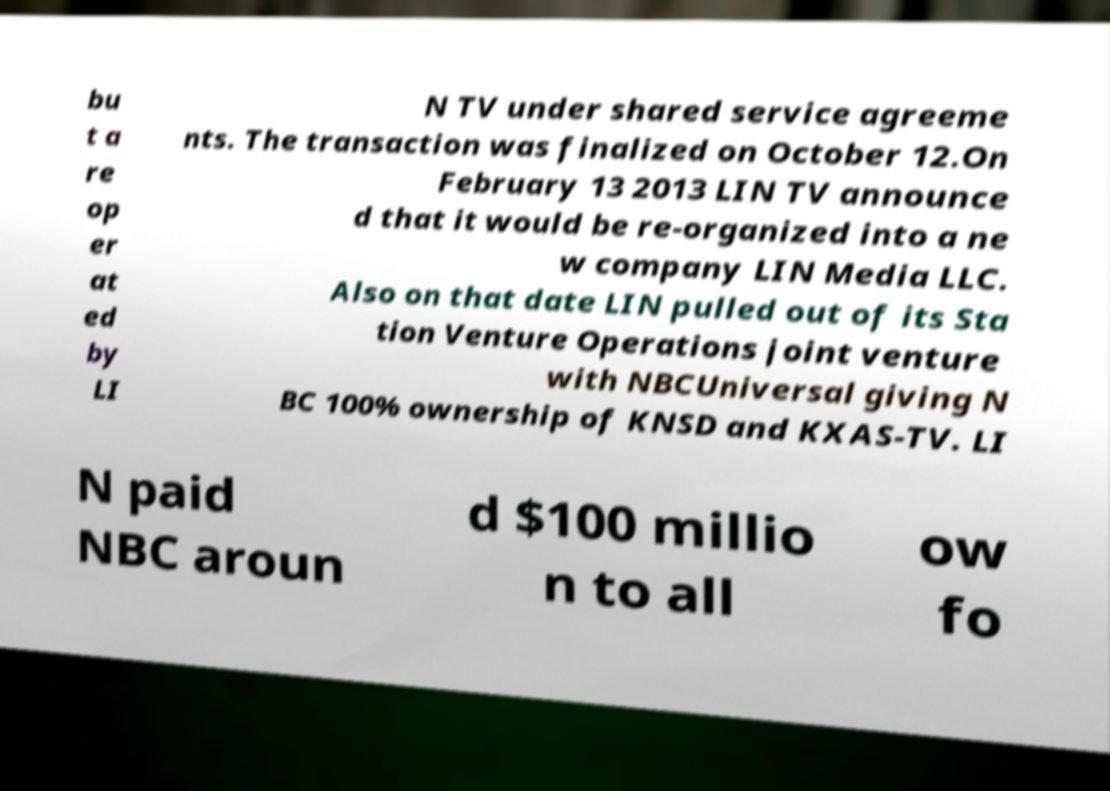Can you accurately transcribe the text from the provided image for me? bu t a re op er at ed by LI N TV under shared service agreeme nts. The transaction was finalized on October 12.On February 13 2013 LIN TV announce d that it would be re-organized into a ne w company LIN Media LLC. Also on that date LIN pulled out of its Sta tion Venture Operations joint venture with NBCUniversal giving N BC 100% ownership of KNSD and KXAS-TV. LI N paid NBC aroun d $100 millio n to all ow fo 